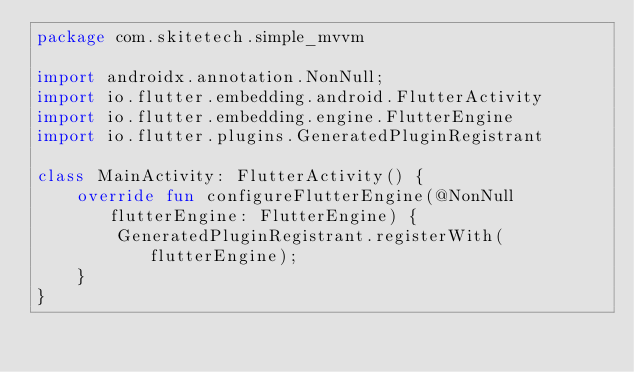<code> <loc_0><loc_0><loc_500><loc_500><_Kotlin_>package com.skitetech.simple_mvvm

import androidx.annotation.NonNull;
import io.flutter.embedding.android.FlutterActivity
import io.flutter.embedding.engine.FlutterEngine
import io.flutter.plugins.GeneratedPluginRegistrant

class MainActivity: FlutterActivity() {
    override fun configureFlutterEngine(@NonNull flutterEngine: FlutterEngine) {
        GeneratedPluginRegistrant.registerWith(flutterEngine);
    }
}
</code> 